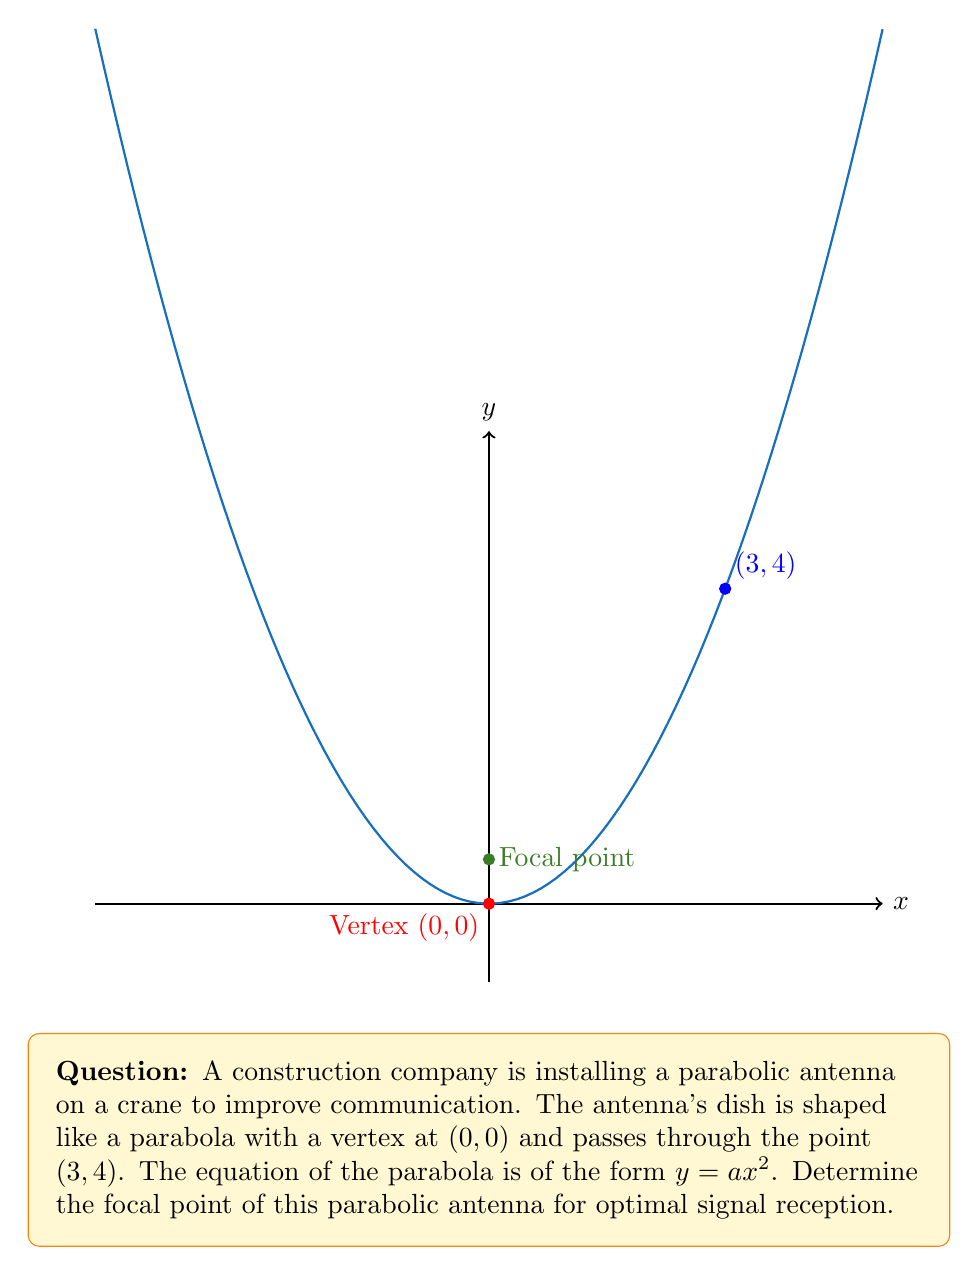Can you answer this question? Let's approach this step-by-step:

1) The general equation of a parabola with vertex at (0, 0) is $y = ax^2$, where $a$ is a constant we need to determine.

2) We know the parabola passes through the point (3, 4). Let's use this to find $a$:
   
   $4 = a(3^2)$
   $4 = 9a$
   $a = \frac{4}{9}$

3) So, the equation of our parabola is $y = \frac{4}{9}x^2$

4) For a parabola in the form $y = ax^2$, the focal point is located at $\left(0, \frac{1}{4a}\right)$

5) Substituting our value of $a$:
   
   Focal point = $\left(0, \frac{1}{4(\frac{4}{9})}\right) = \left(0, \frac{9}{16}\right)$

Therefore, the focal point of the parabolic antenna is at $\left(0, \frac{9}{16}\right)$.
Answer: $\left(0, \frac{9}{16}\right)$ 